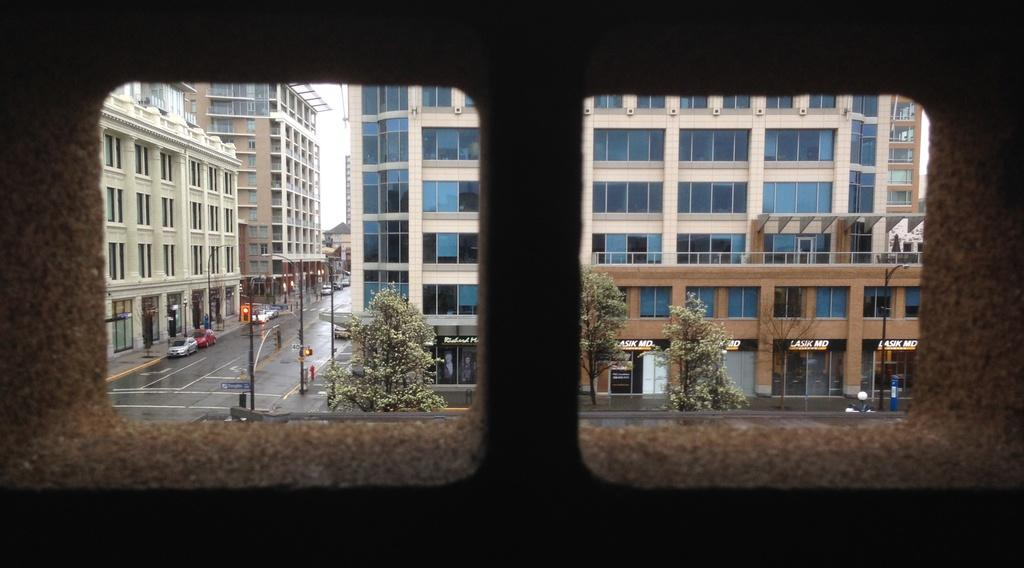What is the main feature of the image? There is a road in the image. What is happening on the road? Vehicles are present on the road. What else can be seen along the road? There are poles with lights and trees visible in the image. What type of structures are present in the image? There are buildings in the image. What part of the sky can be seen in the image? The sky is partially visible in the image. How does the throat of the person walking on the road look like in the image? There is no person walking on the road in the image, so it is not possible to determine the appearance of their throat. 